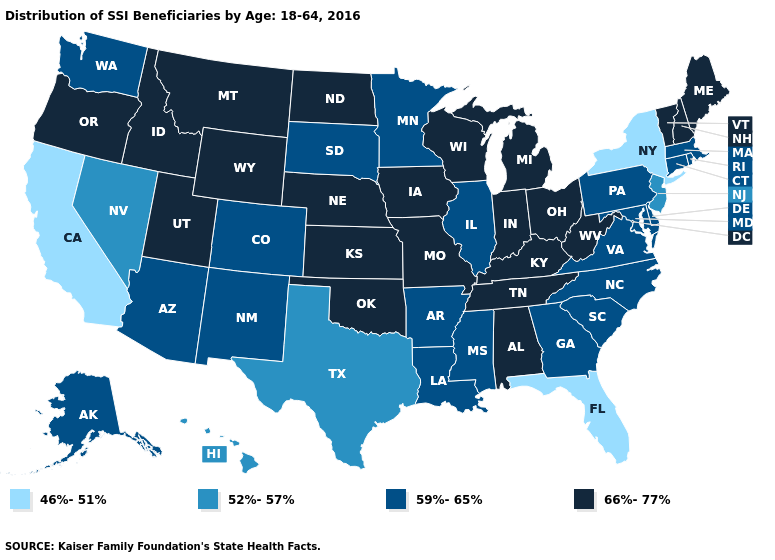What is the lowest value in the MidWest?
Give a very brief answer. 59%-65%. Does Illinois have a higher value than Texas?
Be succinct. Yes. Does the map have missing data?
Be succinct. No. Name the states that have a value in the range 46%-51%?
Answer briefly. California, Florida, New York. Which states have the lowest value in the Northeast?
Keep it brief. New York. Which states have the lowest value in the MidWest?
Give a very brief answer. Illinois, Minnesota, South Dakota. Name the states that have a value in the range 52%-57%?
Concise answer only. Hawaii, Nevada, New Jersey, Texas. What is the highest value in states that border Indiana?
Keep it brief. 66%-77%. What is the value of Arizona?
Quick response, please. 59%-65%. Name the states that have a value in the range 46%-51%?
Quick response, please. California, Florida, New York. Which states hav the highest value in the Northeast?
Keep it brief. Maine, New Hampshire, Vermont. Among the states that border California , does Nevada have the lowest value?
Keep it brief. Yes. Name the states that have a value in the range 59%-65%?
Quick response, please. Alaska, Arizona, Arkansas, Colorado, Connecticut, Delaware, Georgia, Illinois, Louisiana, Maryland, Massachusetts, Minnesota, Mississippi, New Mexico, North Carolina, Pennsylvania, Rhode Island, South Carolina, South Dakota, Virginia, Washington. What is the lowest value in the USA?
Concise answer only. 46%-51%. Does the first symbol in the legend represent the smallest category?
Short answer required. Yes. 